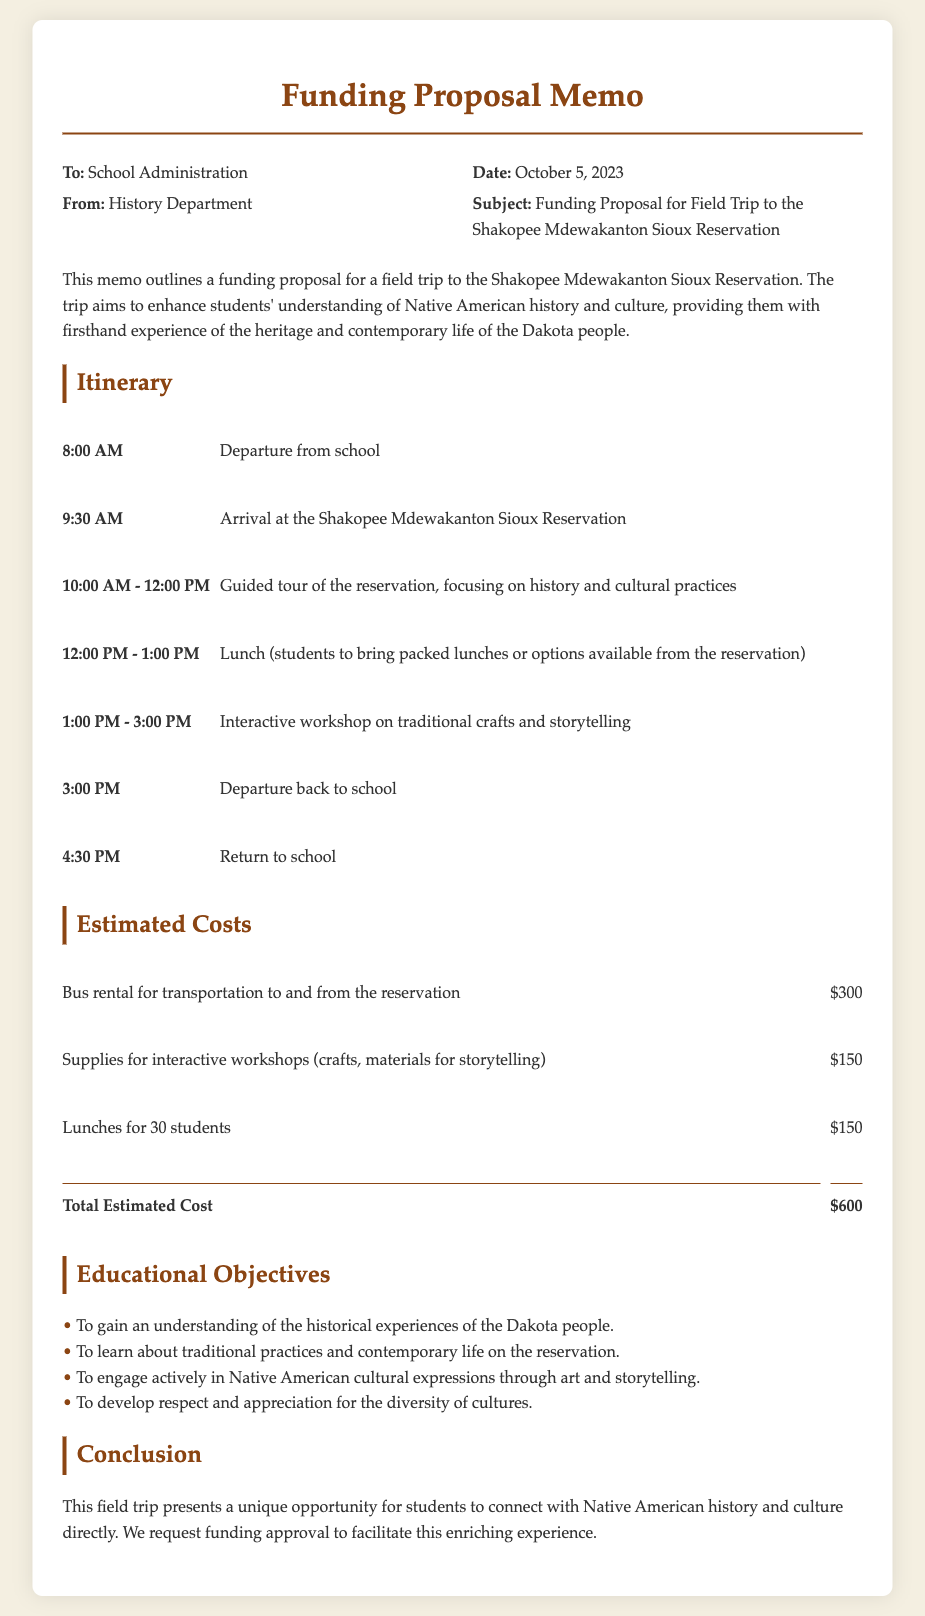What is the date of the memo? The date of the memo is explicitly stated in the document, which is October 5, 2023.
Answer: October 5, 2023 What is the total estimated cost for the trip? The total estimated cost is calculated in the document, and it sums up to $600.
Answer: $600 What time does the trip depart from school? The itinerary details the departure time from school as 8:00 AM.
Answer: 8:00 AM What interactive activity is planned for the students? The document mentions an interactive workshop on traditional crafts and storytelling as part of the itinerary.
Answer: Traditional crafts and storytelling Who is the memo addressed to? The memo is addressed to the School Administration, which is clearly indicated at the beginning.
Answer: School Administration What is one educational objective of the field trip? The document lists multiple educational objectives, one being to gain an understanding of the historical experiences of the Dakota people.
Answer: Understanding historical experiences of the Dakota people How long is the guided tour scheduled to last? According to the itinerary, the guided tour of the reservation is scheduled to last from 10:00 AM to 12:00 PM, totaling 2 hours.
Answer: 2 hours What type of memo is this document classified as? It is classified as a funding proposal memo based on the content and the subject line provided.
Answer: Funding proposal memo What time is the return to school scheduled for? The return to school is scheduled for 4:30 PM, as specified in the itinerary.
Answer: 4:30 PM 